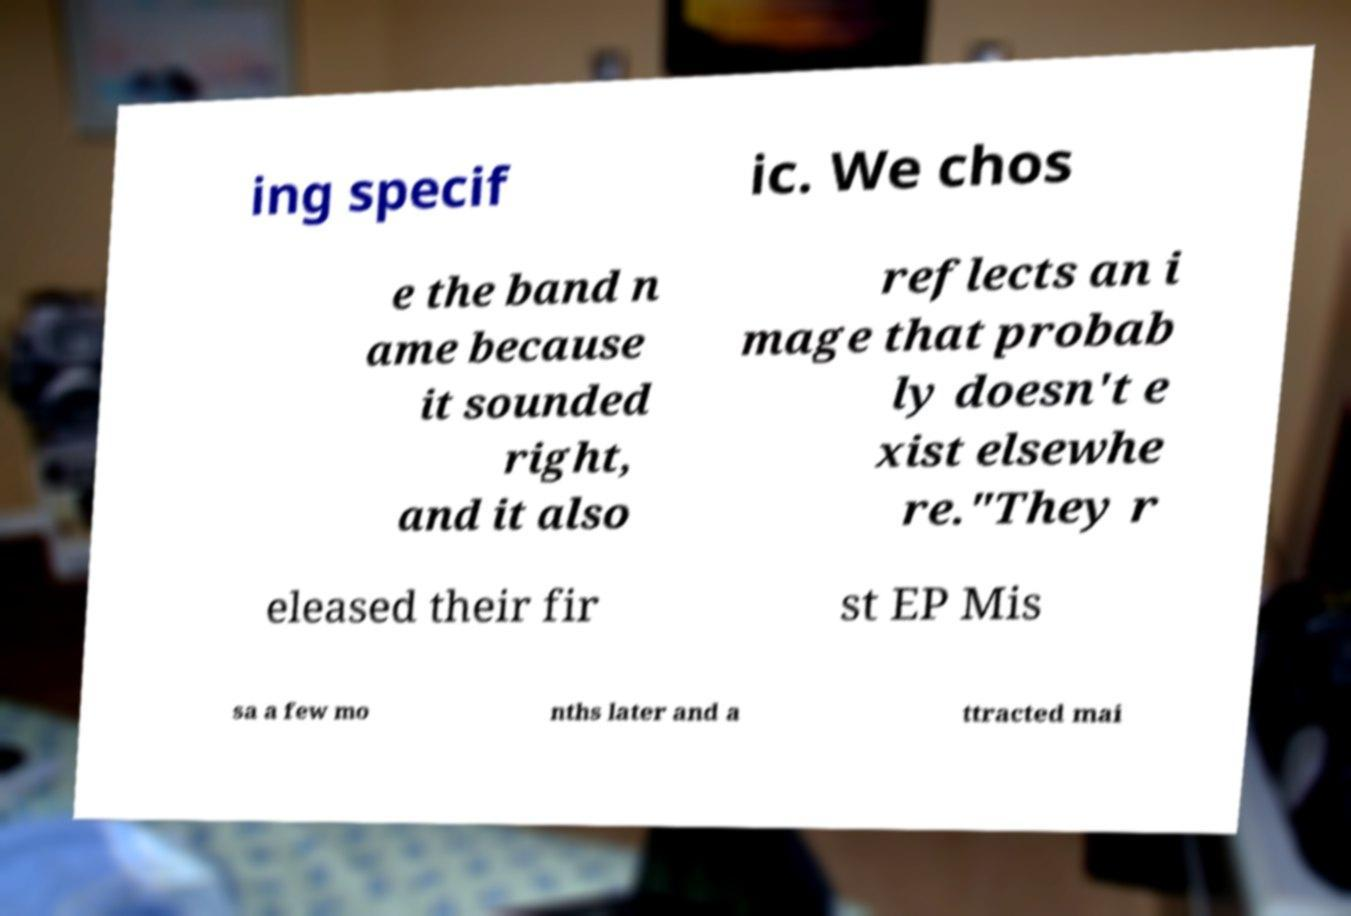Please identify and transcribe the text found in this image. ing specif ic. We chos e the band n ame because it sounded right, and it also reflects an i mage that probab ly doesn't e xist elsewhe re."They r eleased their fir st EP Mis sa a few mo nths later and a ttracted mai 